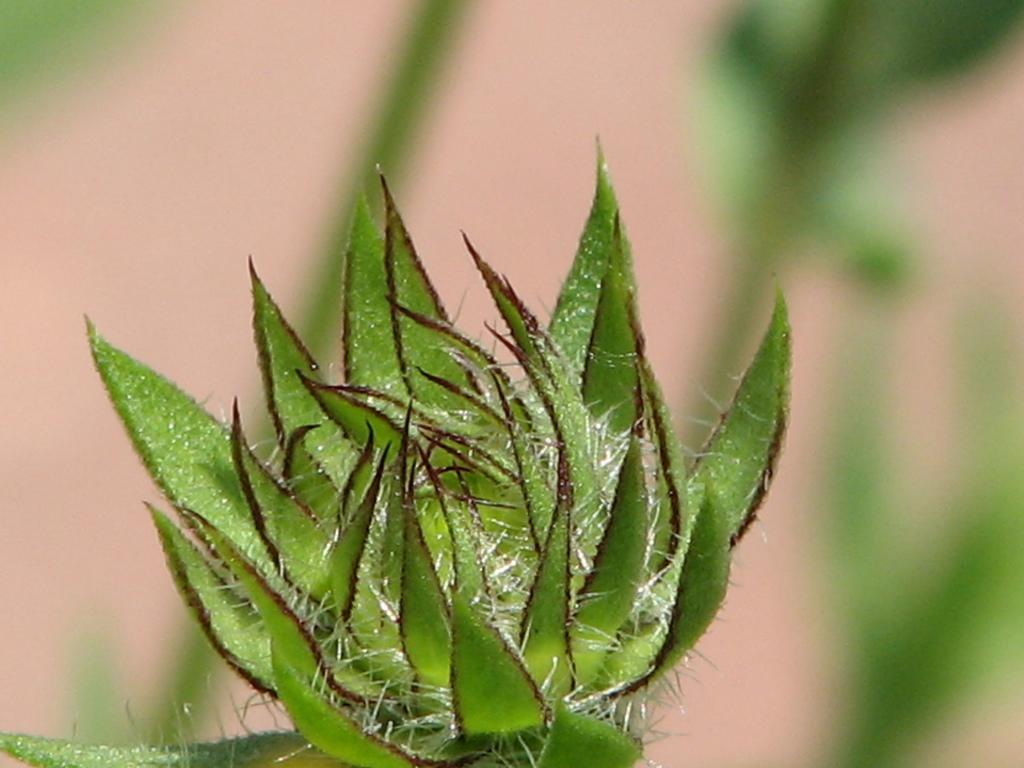What is present in the image? There is a plant in the image. Can you describe the background of the image? The background of the image is blurred. What type of juice is being served on the coast in the image? There is no mention of juice or a coast in the image; it only features a plant and a blurred background. 